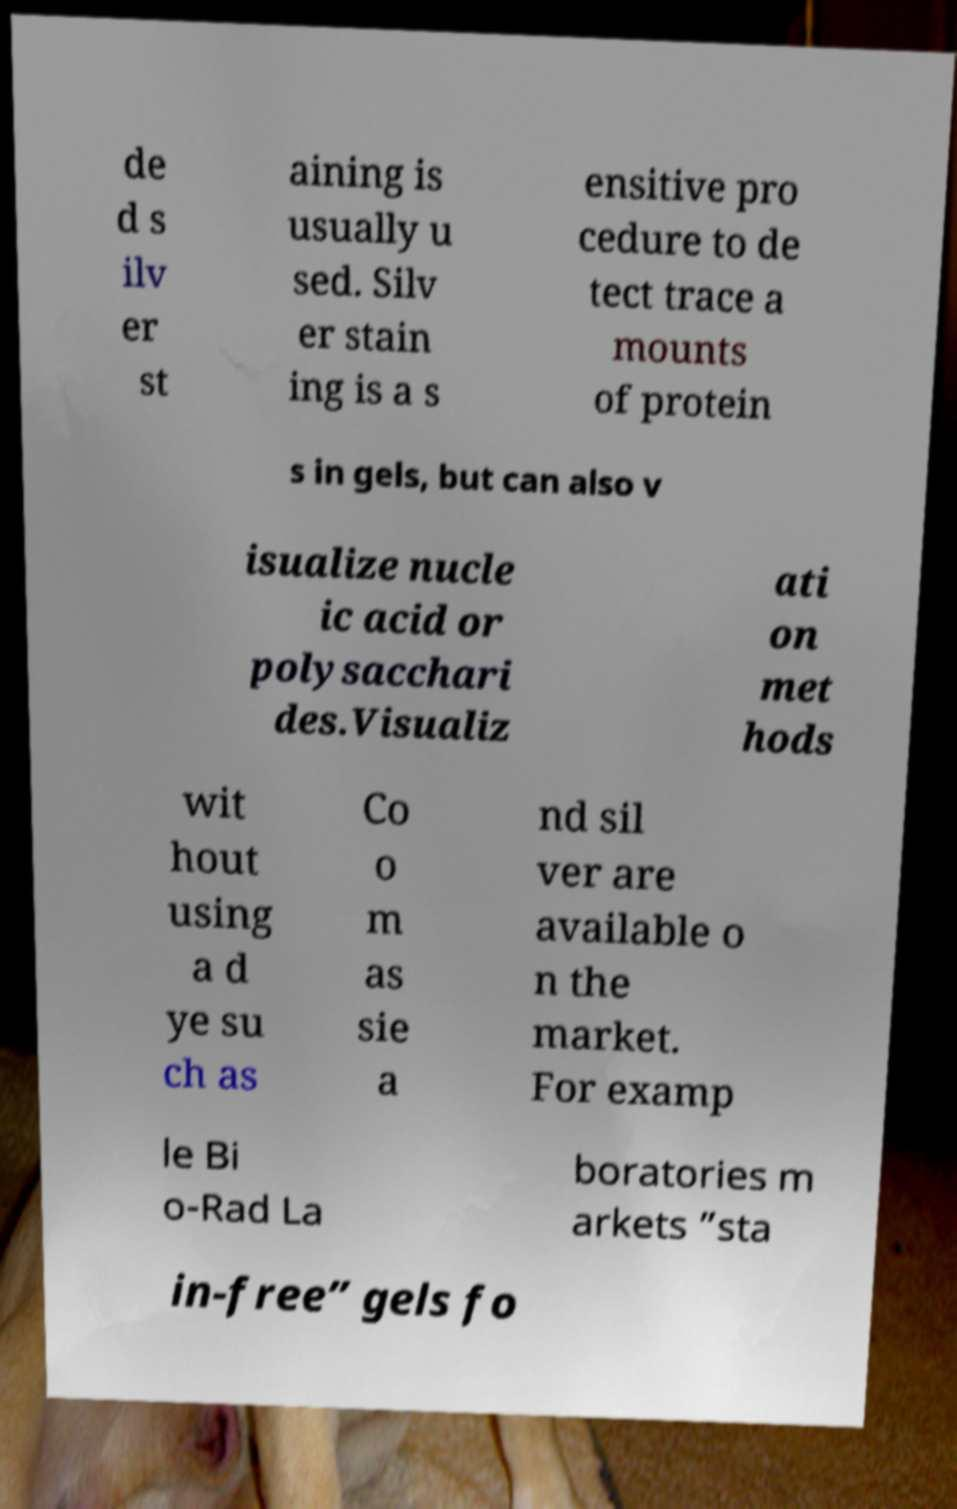Please identify and transcribe the text found in this image. de d s ilv er st aining is usually u sed. Silv er stain ing is a s ensitive pro cedure to de tect trace a mounts of protein s in gels, but can also v isualize nucle ic acid or polysacchari des.Visualiz ati on met hods wit hout using a d ye su ch as Co o m as sie a nd sil ver are available o n the market. For examp le Bi o-Rad La boratories m arkets ”sta in-free” gels fo 